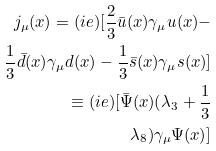Convert formula to latex. <formula><loc_0><loc_0><loc_500><loc_500>j _ { \mu } ( x ) = ( i e ) [ \frac { 2 } { 3 } \bar { u } ( x ) \gamma _ { \mu } u ( x ) - \\ \frac { 1 } { 3 } \bar { d } ( x ) \gamma _ { \mu } d ( x ) - \frac { 1 } { 3 } \bar { s } ( x ) \gamma _ { \mu } s ( x ) ] \\ \equiv ( i e ) [ \bar { \Psi } ( x ) ( \lambda _ { 3 } + \frac { 1 } { 3 } \\ \lambda _ { 8 } ) \gamma _ { \mu } \Psi ( x ) ]</formula> 